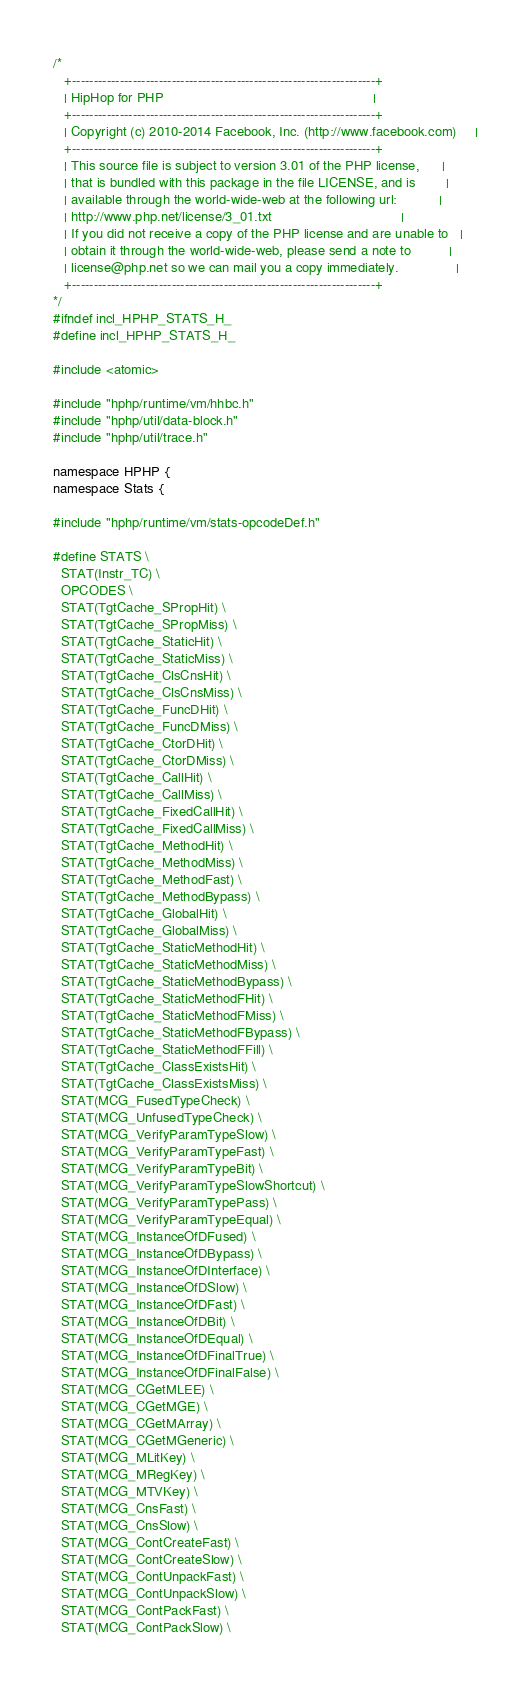<code> <loc_0><loc_0><loc_500><loc_500><_C_>/*
   +----------------------------------------------------------------------+
   | HipHop for PHP                                                       |
   +----------------------------------------------------------------------+
   | Copyright (c) 2010-2014 Facebook, Inc. (http://www.facebook.com)     |
   +----------------------------------------------------------------------+
   | This source file is subject to version 3.01 of the PHP license,      |
   | that is bundled with this package in the file LICENSE, and is        |
   | available through the world-wide-web at the following url:           |
   | http://www.php.net/license/3_01.txt                                  |
   | If you did not receive a copy of the PHP license and are unable to   |
   | obtain it through the world-wide-web, please send a note to          |
   | license@php.net so we can mail you a copy immediately.               |
   +----------------------------------------------------------------------+
*/
#ifndef incl_HPHP_STATS_H_
#define incl_HPHP_STATS_H_

#include <atomic>

#include "hphp/runtime/vm/hhbc.h"
#include "hphp/util/data-block.h"
#include "hphp/util/trace.h"

namespace HPHP {
namespace Stats {

#include "hphp/runtime/vm/stats-opcodeDef.h"

#define STATS \
  STAT(Instr_TC) \
  OPCODES \
  STAT(TgtCache_SPropHit) \
  STAT(TgtCache_SPropMiss) \
  STAT(TgtCache_StaticHit) \
  STAT(TgtCache_StaticMiss) \
  STAT(TgtCache_ClsCnsHit) \
  STAT(TgtCache_ClsCnsMiss) \
  STAT(TgtCache_FuncDHit) \
  STAT(TgtCache_FuncDMiss) \
  STAT(TgtCache_CtorDHit) \
  STAT(TgtCache_CtorDMiss) \
  STAT(TgtCache_CallHit) \
  STAT(TgtCache_CallMiss) \
  STAT(TgtCache_FixedCallHit) \
  STAT(TgtCache_FixedCallMiss) \
  STAT(TgtCache_MethodHit) \
  STAT(TgtCache_MethodMiss) \
  STAT(TgtCache_MethodFast) \
  STAT(TgtCache_MethodBypass) \
  STAT(TgtCache_GlobalHit) \
  STAT(TgtCache_GlobalMiss) \
  STAT(TgtCache_StaticMethodHit) \
  STAT(TgtCache_StaticMethodMiss) \
  STAT(TgtCache_StaticMethodBypass) \
  STAT(TgtCache_StaticMethodFHit) \
  STAT(TgtCache_StaticMethodFMiss) \
  STAT(TgtCache_StaticMethodFBypass) \
  STAT(TgtCache_StaticMethodFFill) \
  STAT(TgtCache_ClassExistsHit) \
  STAT(TgtCache_ClassExistsMiss) \
  STAT(MCG_FusedTypeCheck) \
  STAT(MCG_UnfusedTypeCheck) \
  STAT(MCG_VerifyParamTypeSlow) \
  STAT(MCG_VerifyParamTypeFast) \
  STAT(MCG_VerifyParamTypeBit) \
  STAT(MCG_VerifyParamTypeSlowShortcut) \
  STAT(MCG_VerifyParamTypePass) \
  STAT(MCG_VerifyParamTypeEqual) \
  STAT(MCG_InstanceOfDFused) \
  STAT(MCG_InstanceOfDBypass) \
  STAT(MCG_InstanceOfDInterface) \
  STAT(MCG_InstanceOfDSlow) \
  STAT(MCG_InstanceOfDFast) \
  STAT(MCG_InstanceOfDBit) \
  STAT(MCG_InstanceOfDEqual) \
  STAT(MCG_InstanceOfDFinalTrue) \
  STAT(MCG_InstanceOfDFinalFalse) \
  STAT(MCG_CGetMLEE) \
  STAT(MCG_CGetMGE) \
  STAT(MCG_CGetMArray) \
  STAT(MCG_CGetMGeneric) \
  STAT(MCG_MLitKey) \
  STAT(MCG_MRegKey) \
  STAT(MCG_MTVKey) \
  STAT(MCG_CnsFast) \
  STAT(MCG_CnsSlow) \
  STAT(MCG_ContCreateFast) \
  STAT(MCG_ContCreateSlow) \
  STAT(MCG_ContUnpackFast) \
  STAT(MCG_ContUnpackSlow) \
  STAT(MCG_ContPackFast) \
  STAT(MCG_ContPackSlow) \</code> 